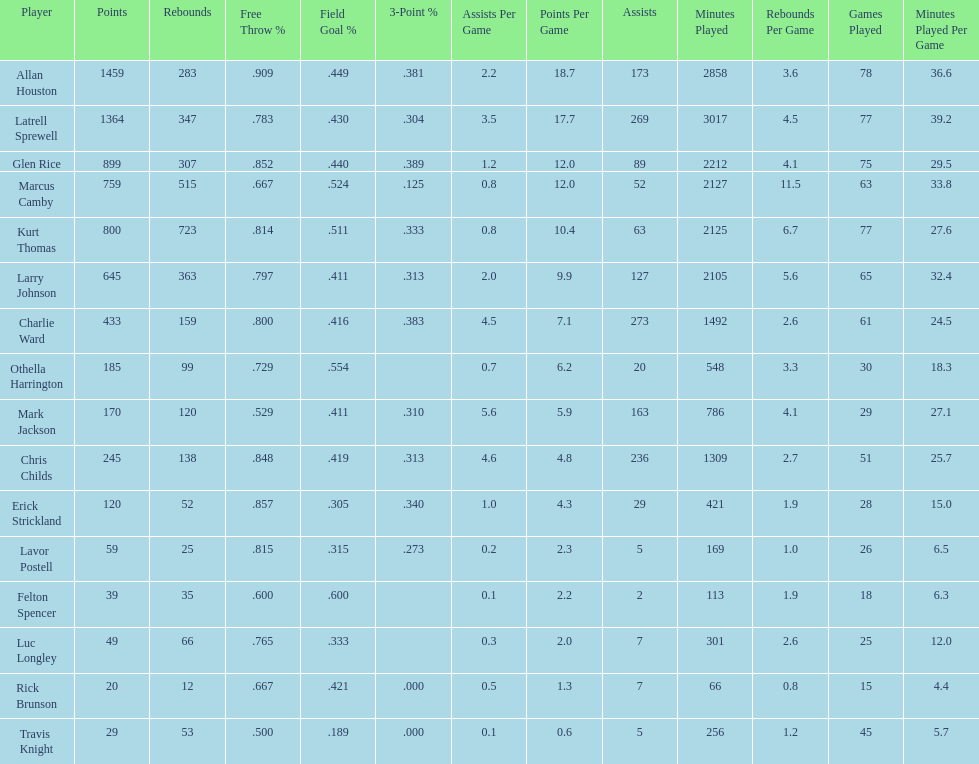How many games did larry johnson play? 65. 